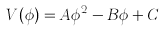Convert formula to latex. <formula><loc_0><loc_0><loc_500><loc_500>V ( \phi ) = A \phi ^ { 2 } - B \phi + C</formula> 